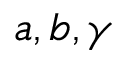<formula> <loc_0><loc_0><loc_500><loc_500>a , b , \gamma</formula> 